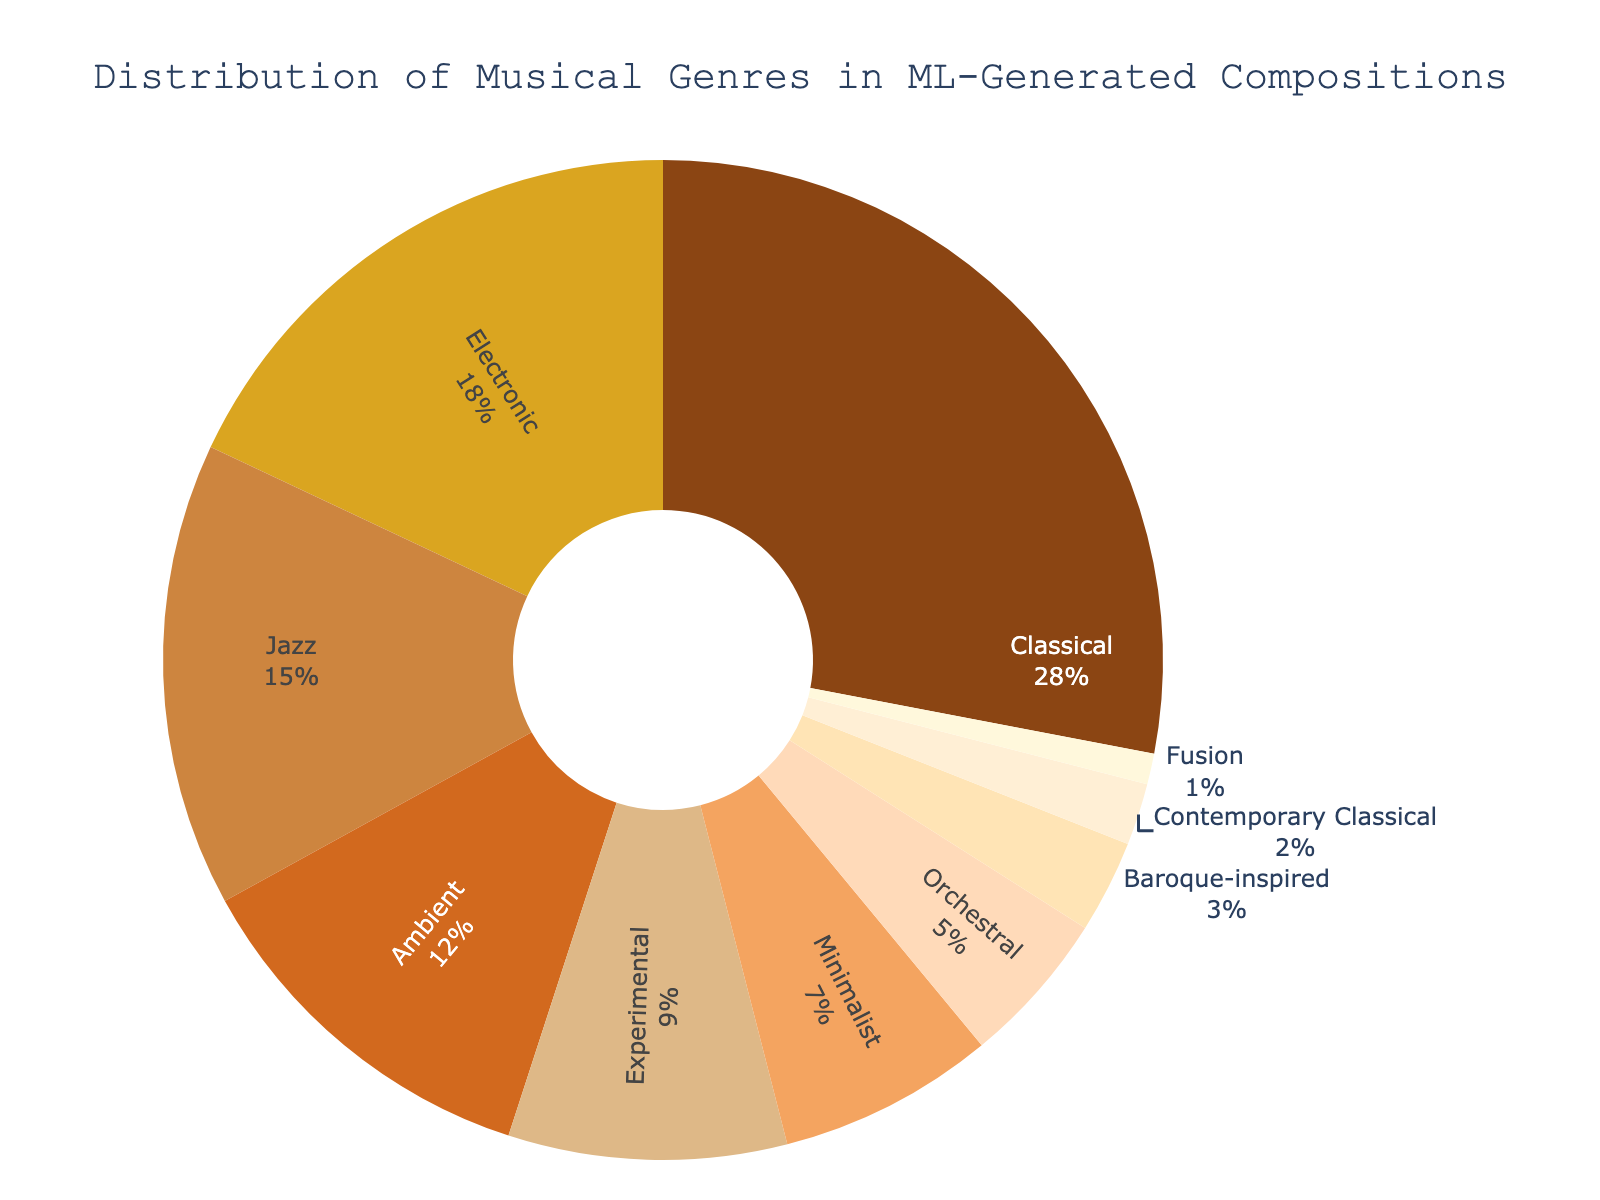What's the largest genre in the distribution? The pie chart shows the distribution of musical genres, and the largest section represents the classical genre with 28%.
Answer: Classical Which genre has the smallest representation? The smallest section in the pie chart corresponds to Fusion, which has a value of 1%.
Answer: Fusion How much more is the percentage of Classical compared to Electronic? The percentage of Classical is 28%, and for Electronic, it is 18%. The difference is 28 - 18 = 10%.
Answer: 10% What's the combined percentage of Ambient and Experimental genres? The Ambient genre has 12% and the Experimental genre 9%. Adding them together, 12 + 9 = 21%.
Answer: 21% Is Jazz more popular or less popular than Minimalist according to the chart? Jazz has 15% representation, while Minimalist has 7%. Therefore, Jazz is more popular than Minimalist.
Answer: More popular What percentage of the compositions is classified under Orchestral and Baroque-inspired combined? The Orchestral genre accounts for 5% and Baroque-inspired for 3%. Summing them gives 5 + 3 = 8%.
Answer: 8% Which genre appears immediately after Jazz in terms of percentage size? According to the chart, immediately after Jazz (15%) comes Ambient (12%).
Answer: Ambient What's the average percentage of the top three genres? The top three genres are Classical (28%), Electronic (18%), and Jazz (15%). Their average is (28 + 18 + 15) / 3 = 61 / 3 = 20.33%.
Answer: 20.33% Are there more compositions in Experimental or Contemporary Classical? Experimental accounts for 9%, while Contemporary Classical is 2%. Thus, Experimental has more compositions.
Answer: Experimental What color represents the Minimalist genre in the pie chart? According to the given data, the Minimalist genre color is light orange.
Answer: Light orange 